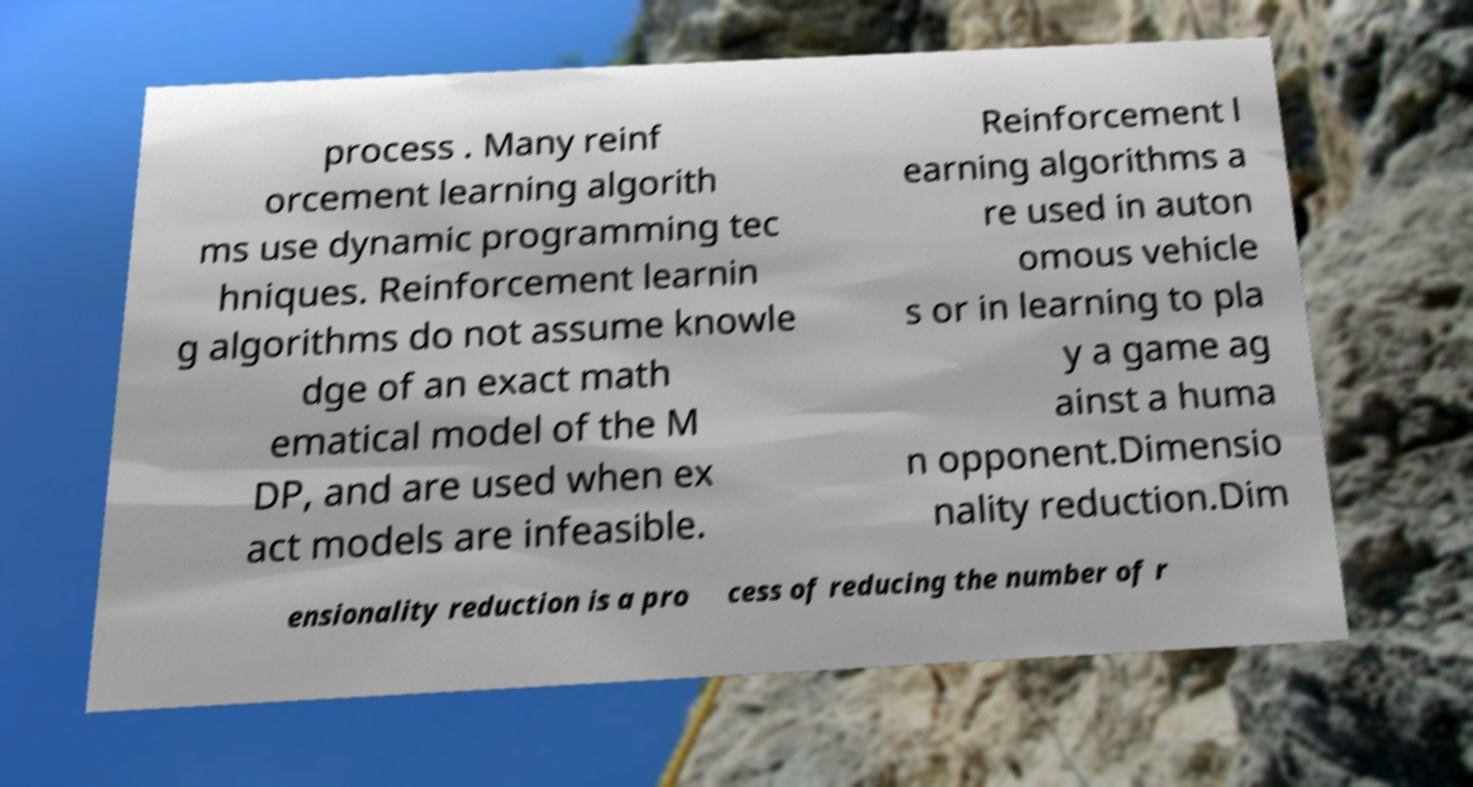Please identify and transcribe the text found in this image. process . Many reinf orcement learning algorith ms use dynamic programming tec hniques. Reinforcement learnin g algorithms do not assume knowle dge of an exact math ematical model of the M DP, and are used when ex act models are infeasible. Reinforcement l earning algorithms a re used in auton omous vehicle s or in learning to pla y a game ag ainst a huma n opponent.Dimensio nality reduction.Dim ensionality reduction is a pro cess of reducing the number of r 